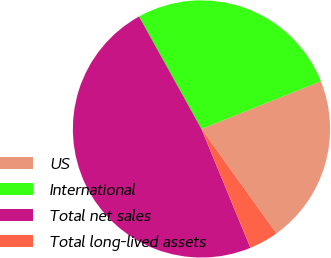Convert chart to OTSL. <chart><loc_0><loc_0><loc_500><loc_500><pie_chart><fcel>US<fcel>International<fcel>Total net sales<fcel>Total long-lived assets<nl><fcel>21.14%<fcel>27.01%<fcel>48.15%<fcel>3.69%<nl></chart> 